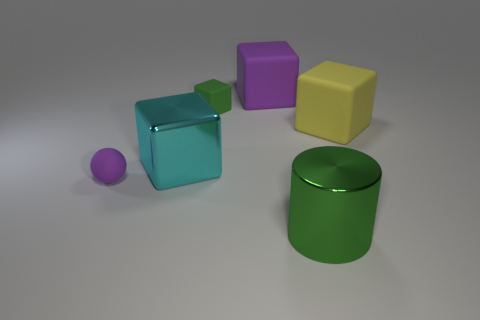Subtract all large metal blocks. How many blocks are left? 3 Subtract all blue cubes. Subtract all brown cylinders. How many cubes are left? 4 Add 1 blue cylinders. How many objects exist? 7 Subtract all balls. How many objects are left? 5 Subtract all yellow matte objects. Subtract all yellow matte things. How many objects are left? 4 Add 6 purple matte things. How many purple matte things are left? 8 Add 4 balls. How many balls exist? 5 Subtract 0 blue spheres. How many objects are left? 6 